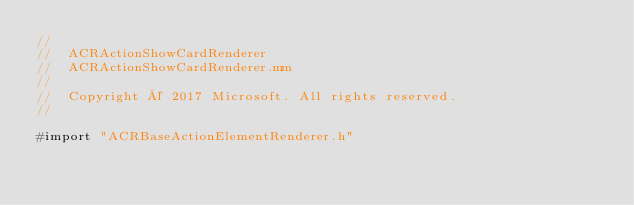Convert code to text. <code><loc_0><loc_0><loc_500><loc_500><_ObjectiveC_>//
//  ACRActionShowCardRenderer
//  ACRActionShowCardRenderer.mm
//
//  Copyright © 2017 Microsoft. All rights reserved.
//

#import "ACRBaseActionElementRenderer.h"</code> 